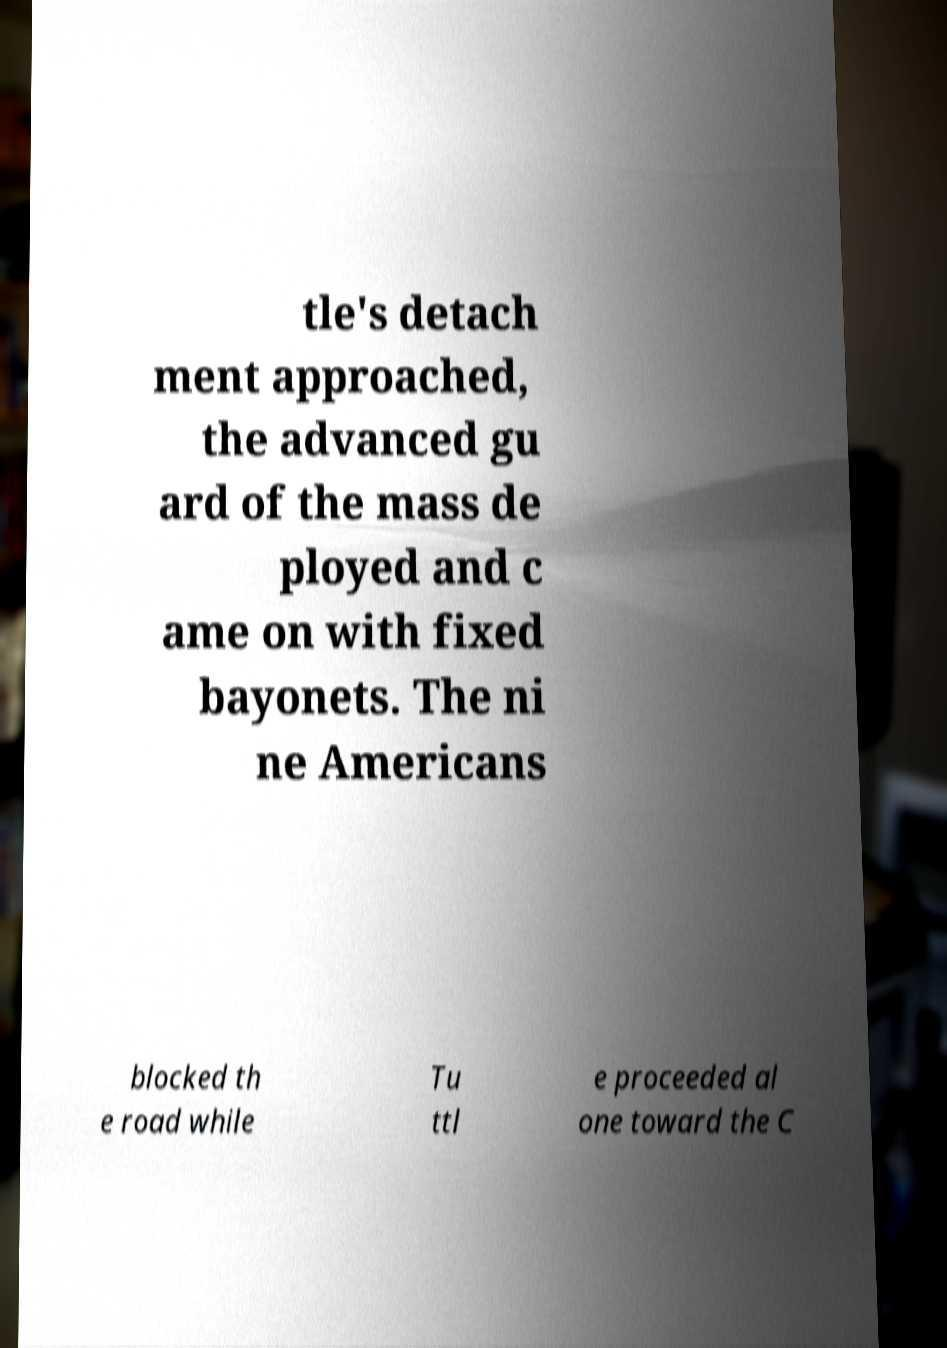Please read and relay the text visible in this image. What does it say? tle's detach ment approached, the advanced gu ard of the mass de ployed and c ame on with fixed bayonets. The ni ne Americans blocked th e road while Tu ttl e proceeded al one toward the C 